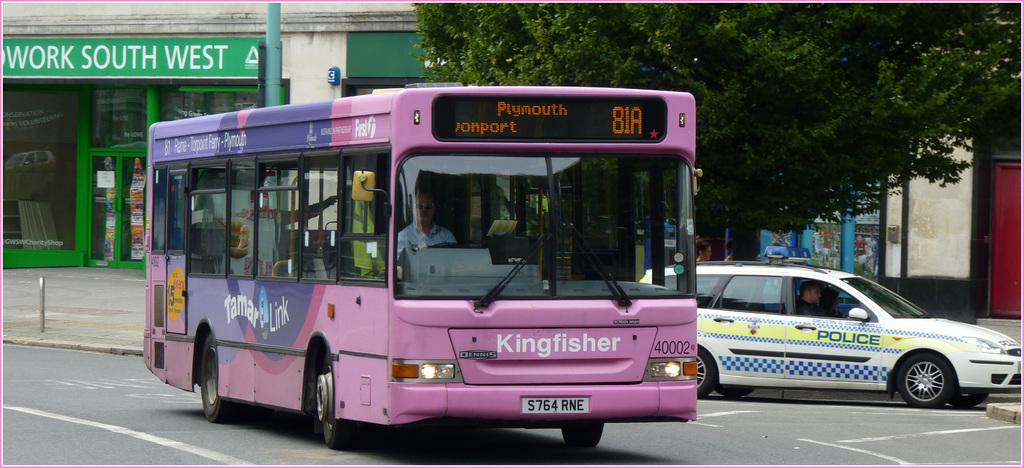What can be seen on the road in the image? There are vehicles on the road in the image. What is visible in the background of the image? There are buildings, poles, and trees in the background of the image. Is the queen present in the image, standing next to the vehicles? There is no queen present in the image; it features vehicles on the road and buildings, poles, and trees in the background. Can you see a flame coming from any of the vehicles in the image? There is no flame visible in the image; it only shows vehicles on the road and the background elements. 